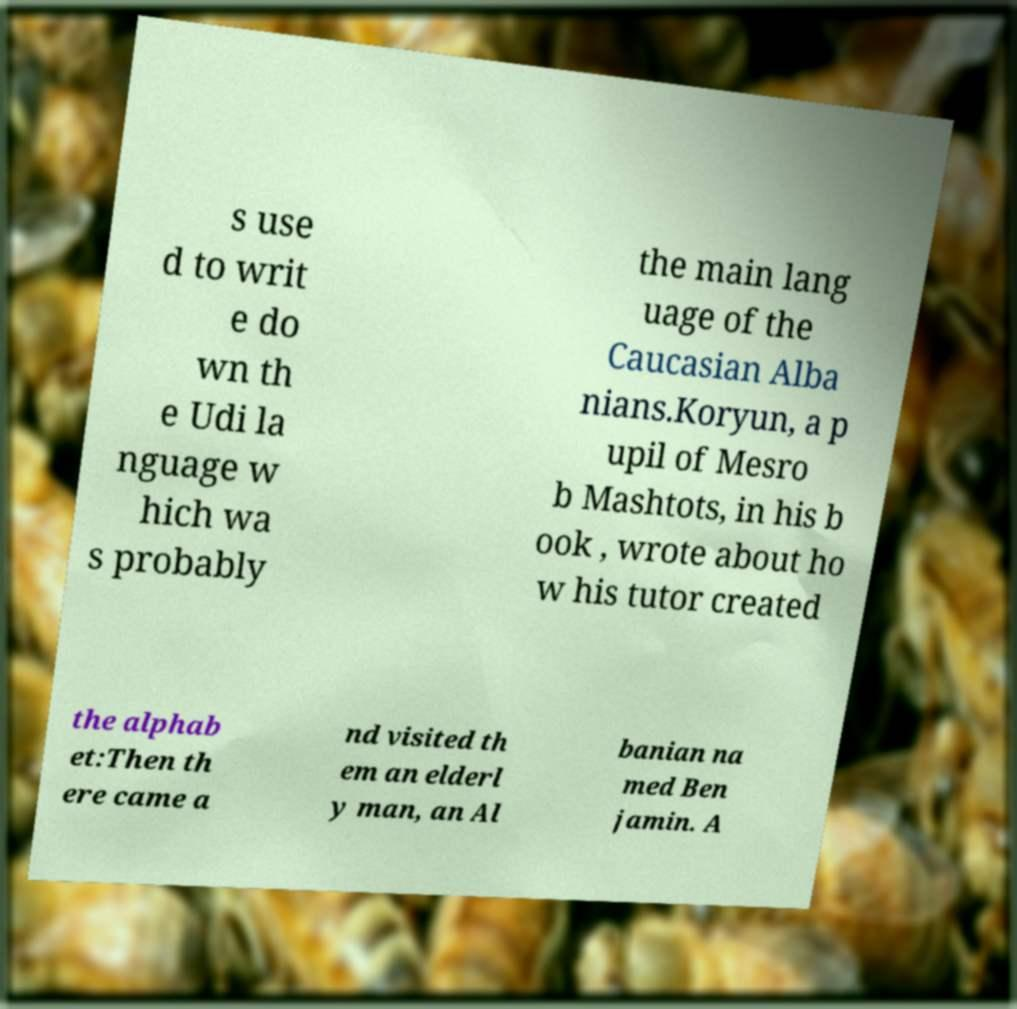Could you assist in decoding the text presented in this image and type it out clearly? s use d to writ e do wn th e Udi la nguage w hich wa s probably the main lang uage of the Caucasian Alba nians.Koryun, a p upil of Mesro b Mashtots, in his b ook , wrote about ho w his tutor created the alphab et:Then th ere came a nd visited th em an elderl y man, an Al banian na med Ben jamin. A 